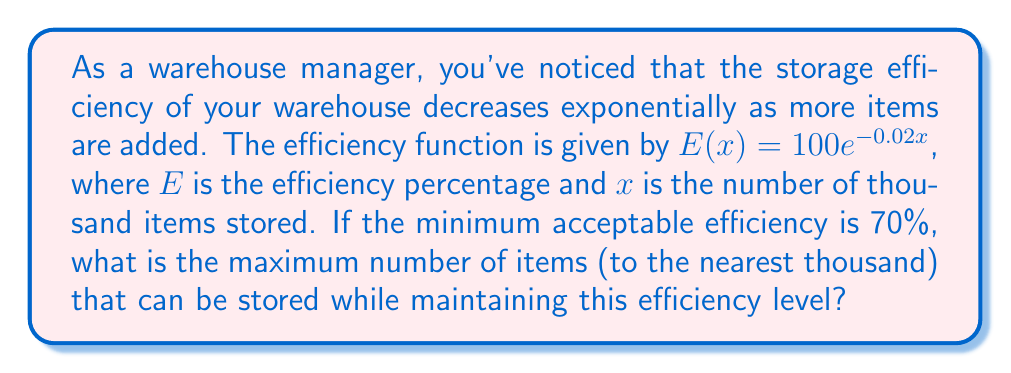What is the answer to this math problem? Let's approach this step-by-step:

1) We're given the efficiency function: $E(x) = 100e^{-0.02x}$

2) We need to find $x$ when $E(x) = 70$ (the minimum acceptable efficiency)

3) Let's set up the equation:
   $70 = 100e^{-0.02x}$

4) Divide both sides by 100:
   $0.7 = e^{-0.02x}$

5) Take the natural log of both sides:
   $\ln(0.7) = \ln(e^{-0.02x})$

6) Simplify the right side using the properties of logarithms:
   $\ln(0.7) = -0.02x$

7) Divide both sides by -0.02:
   $\frac{\ln(0.7)}{-0.02} = x$

8) Calculate:
   $x \approx 17.82$

9) Since $x$ represents thousands of items and we need to round to the nearest thousand, our final answer is 18 thousand items.
Answer: 18,000 items 